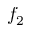<formula> <loc_0><loc_0><loc_500><loc_500>f _ { 2 }</formula> 